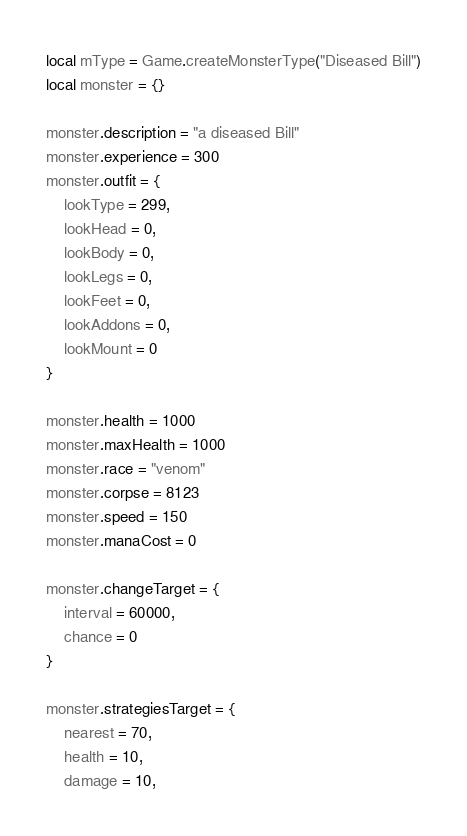<code> <loc_0><loc_0><loc_500><loc_500><_Lua_>local mType = Game.createMonsterType("Diseased Bill")
local monster = {}

monster.description = "a diseased Bill"
monster.experience = 300
monster.outfit = {
	lookType = 299,
	lookHead = 0,
	lookBody = 0,
	lookLegs = 0,
	lookFeet = 0,
	lookAddons = 0,
	lookMount = 0
}

monster.health = 1000
monster.maxHealth = 1000
monster.race = "venom"
monster.corpse = 8123
monster.speed = 150
monster.manaCost = 0

monster.changeTarget = {
	interval = 60000,
	chance = 0
}

monster.strategiesTarget = {
	nearest = 70,
	health = 10,
	damage = 10,</code> 